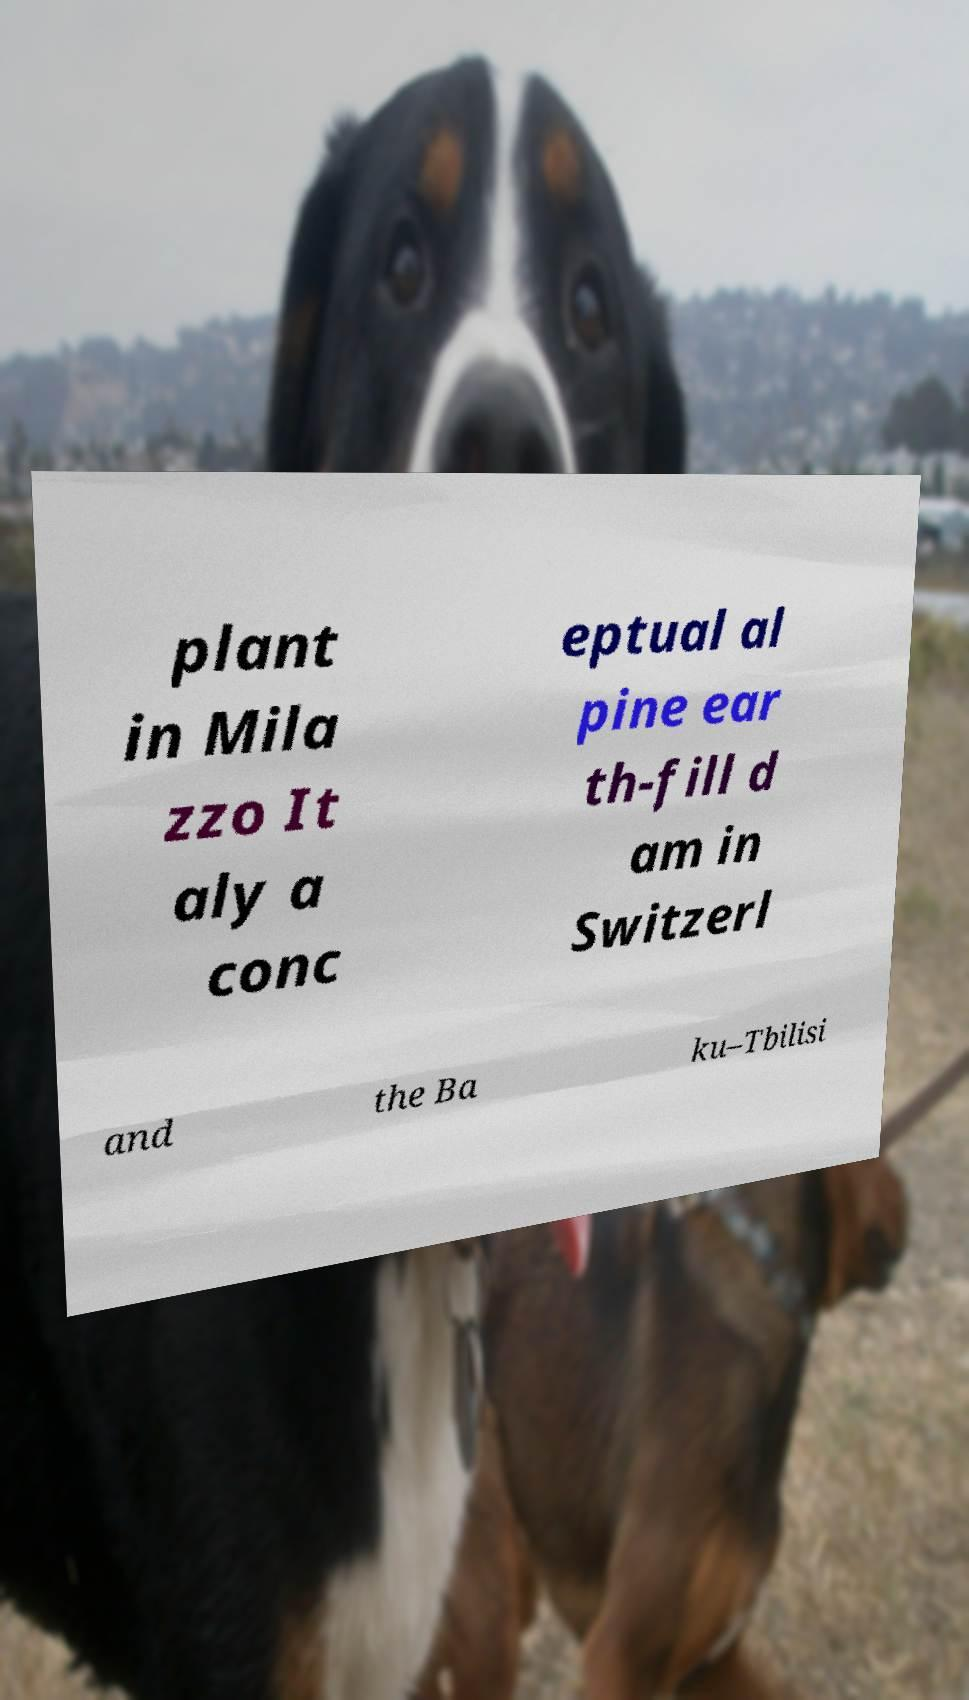Could you assist in decoding the text presented in this image and type it out clearly? plant in Mila zzo It aly a conc eptual al pine ear th-fill d am in Switzerl and the Ba ku–Tbilisi 